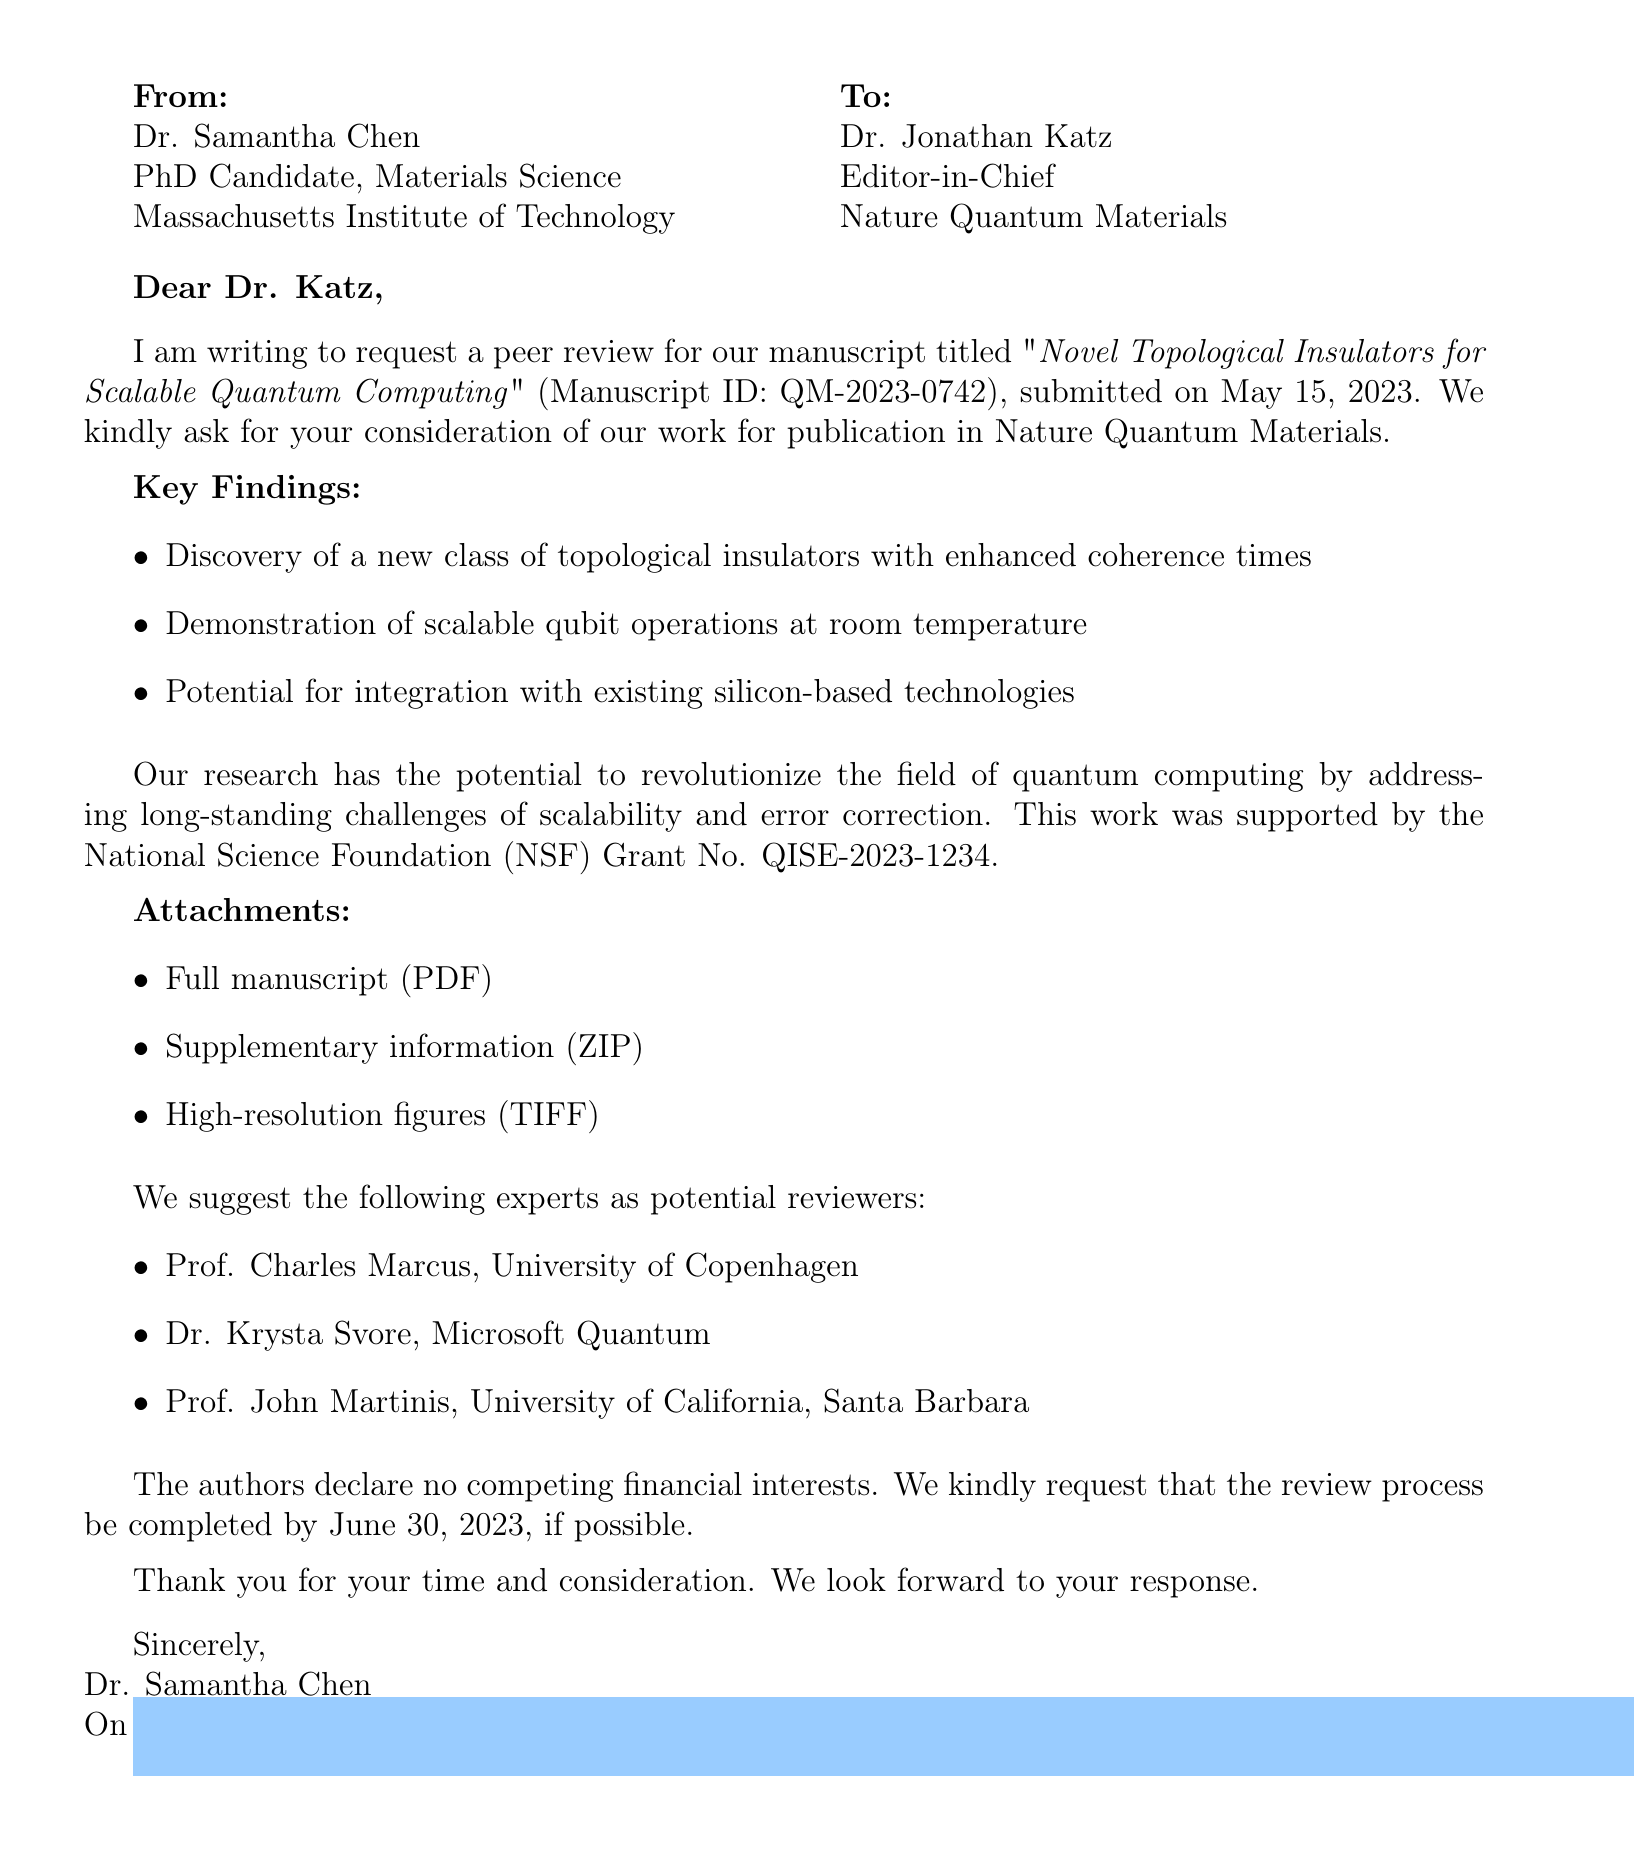What is the title of the manuscript? The title of the manuscript is explicitly mentioned in the document as “Novel Topological Insulators for Scalable Quantum Computing.”
Answer: Novel Topological Insulators for Scalable Quantum Computing Who are the authors of the paper? The authors of the paper are listed in the document, comprising Samantha Chen, Prof. Michael Strano, and Dr. Liang Fu.
Answer: Samantha Chen, Prof. Michael Strano, Dr. Liang Fu When was the manuscript submitted? The submission date of the manuscript is provided in the document as May 15, 2023.
Answer: May 15, 2023 What is the review deadline? The document specifies the review deadline, which is set for June 30, 2023.
Answer: June 30, 2023 What is one key finding of the research? The document contains several key findings; for instance, one is the "discovery of a new class of topological insulators with enhanced coherence times."
Answer: discovery of a new class of topological insulators with enhanced coherence times What funding source supported this research? The funding source is mentioned in the document, referencing the "National Science Foundation (NSF) Grant No. QISE-2023-1234."
Answer: National Science Foundation (NSF) Grant No. QISE-2023-1234 Who is the recipient of the email? The recipient's name and title are clearly stated as Dr. Jonathan Katz, Editor-in-Chief.
Answer: Dr. Jonathan Katz What is the suggested reviewer's affiliation of Prof. Charles Marcus? The document states that Prof. Charles Marcus is associated with the University of Copenhagen.
Answer: University of Copenhagen 